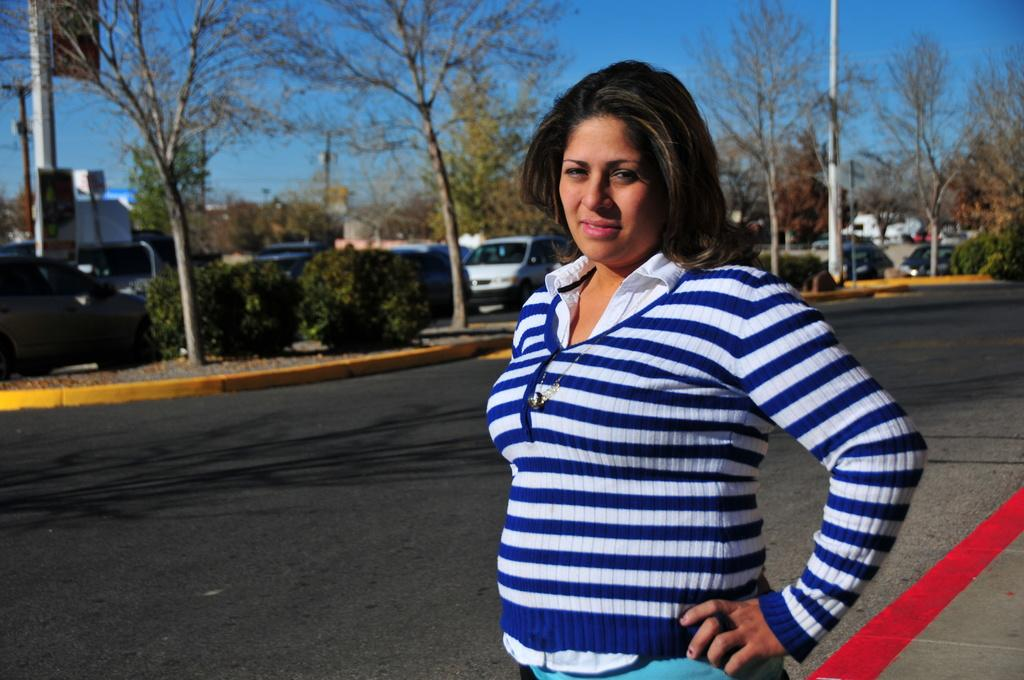Who is the main subject in the image? There is a woman standing in the front of the image. What can be seen in the background of the image? There are plants, trees, vehicles, a house, and the sky visible in the background of the image. Can you hear the squirrel crying in the image? There is no squirrel or crying sound present in the image. 